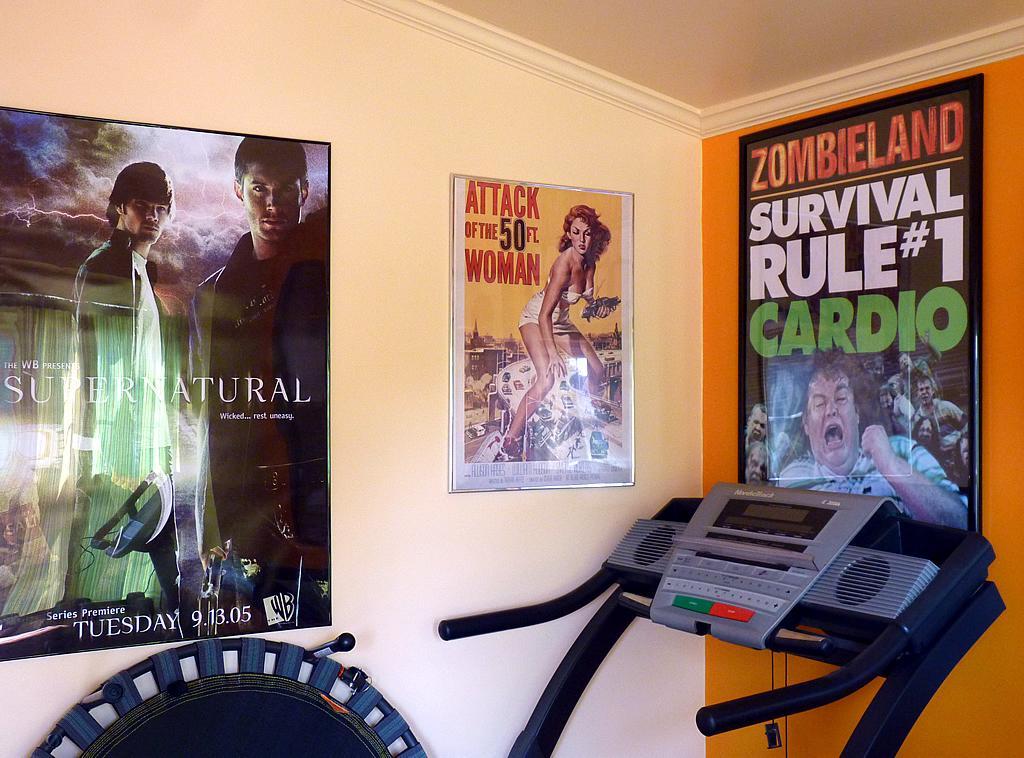Could you give a brief overview of what you see in this image? In this picture I can see there are few posters pasted on the wall and there is a treadmill, with few buttons. 